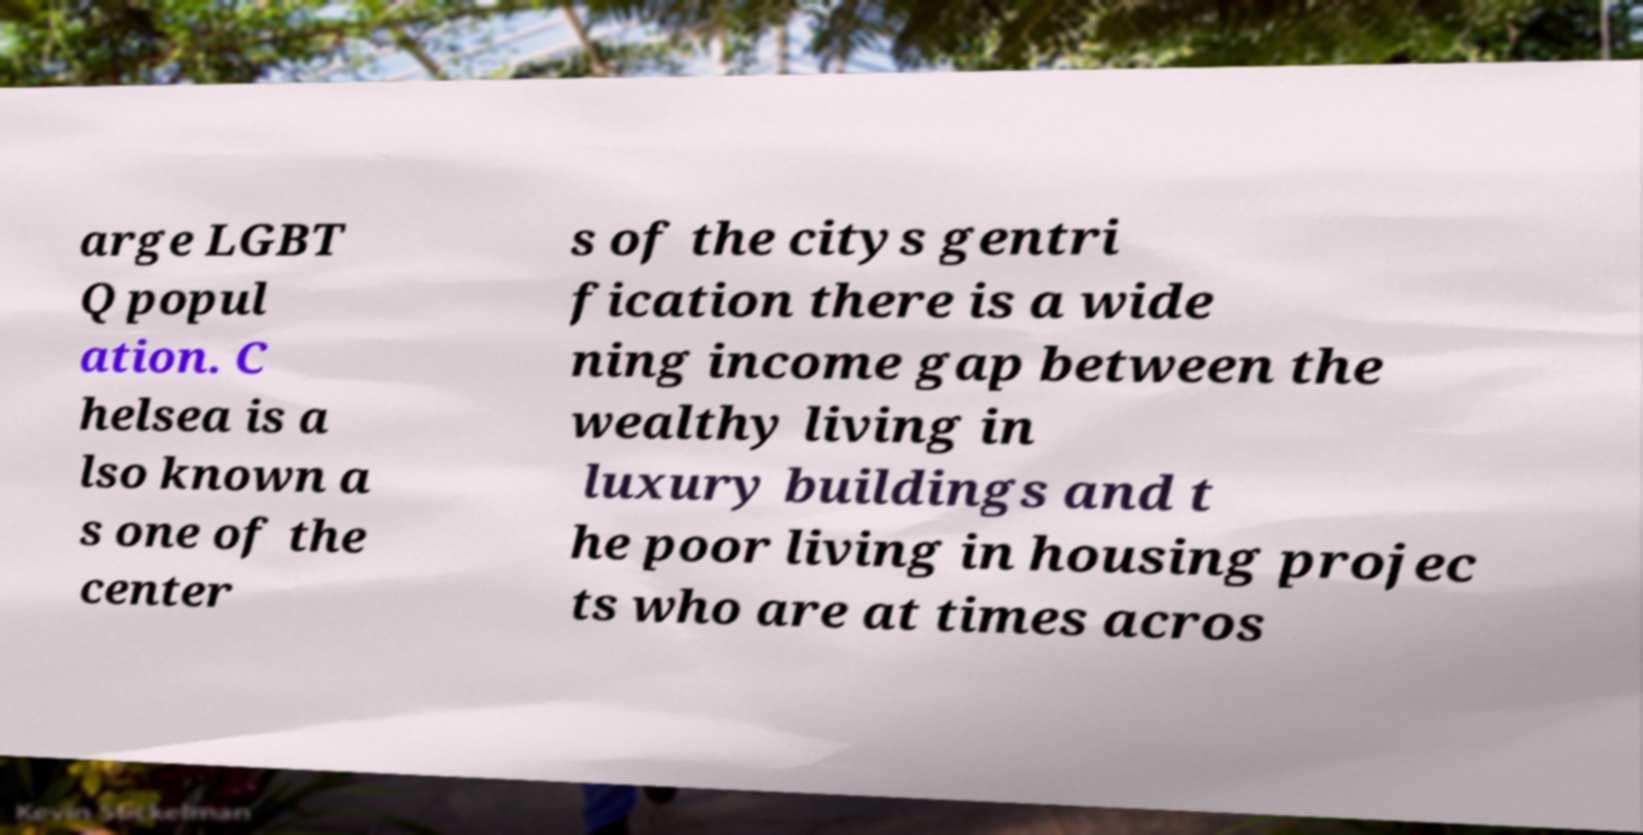I need the written content from this picture converted into text. Can you do that? arge LGBT Q popul ation. C helsea is a lso known a s one of the center s of the citys gentri fication there is a wide ning income gap between the wealthy living in luxury buildings and t he poor living in housing projec ts who are at times acros 